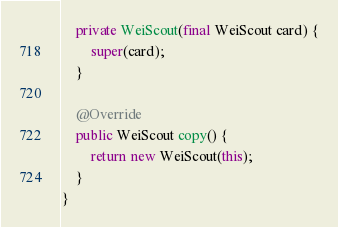<code> <loc_0><loc_0><loc_500><loc_500><_Java_>
    private WeiScout(final WeiScout card) {
        super(card);
    }

    @Override
    public WeiScout copy() {
        return new WeiScout(this);
    }
}
</code> 